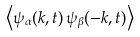Convert formula to latex. <formula><loc_0><loc_0><loc_500><loc_500>\left \langle { \psi _ { \alpha } } ( k , t ) \, { \psi _ { \beta } } ( - k , t ) \right \rangle</formula> 